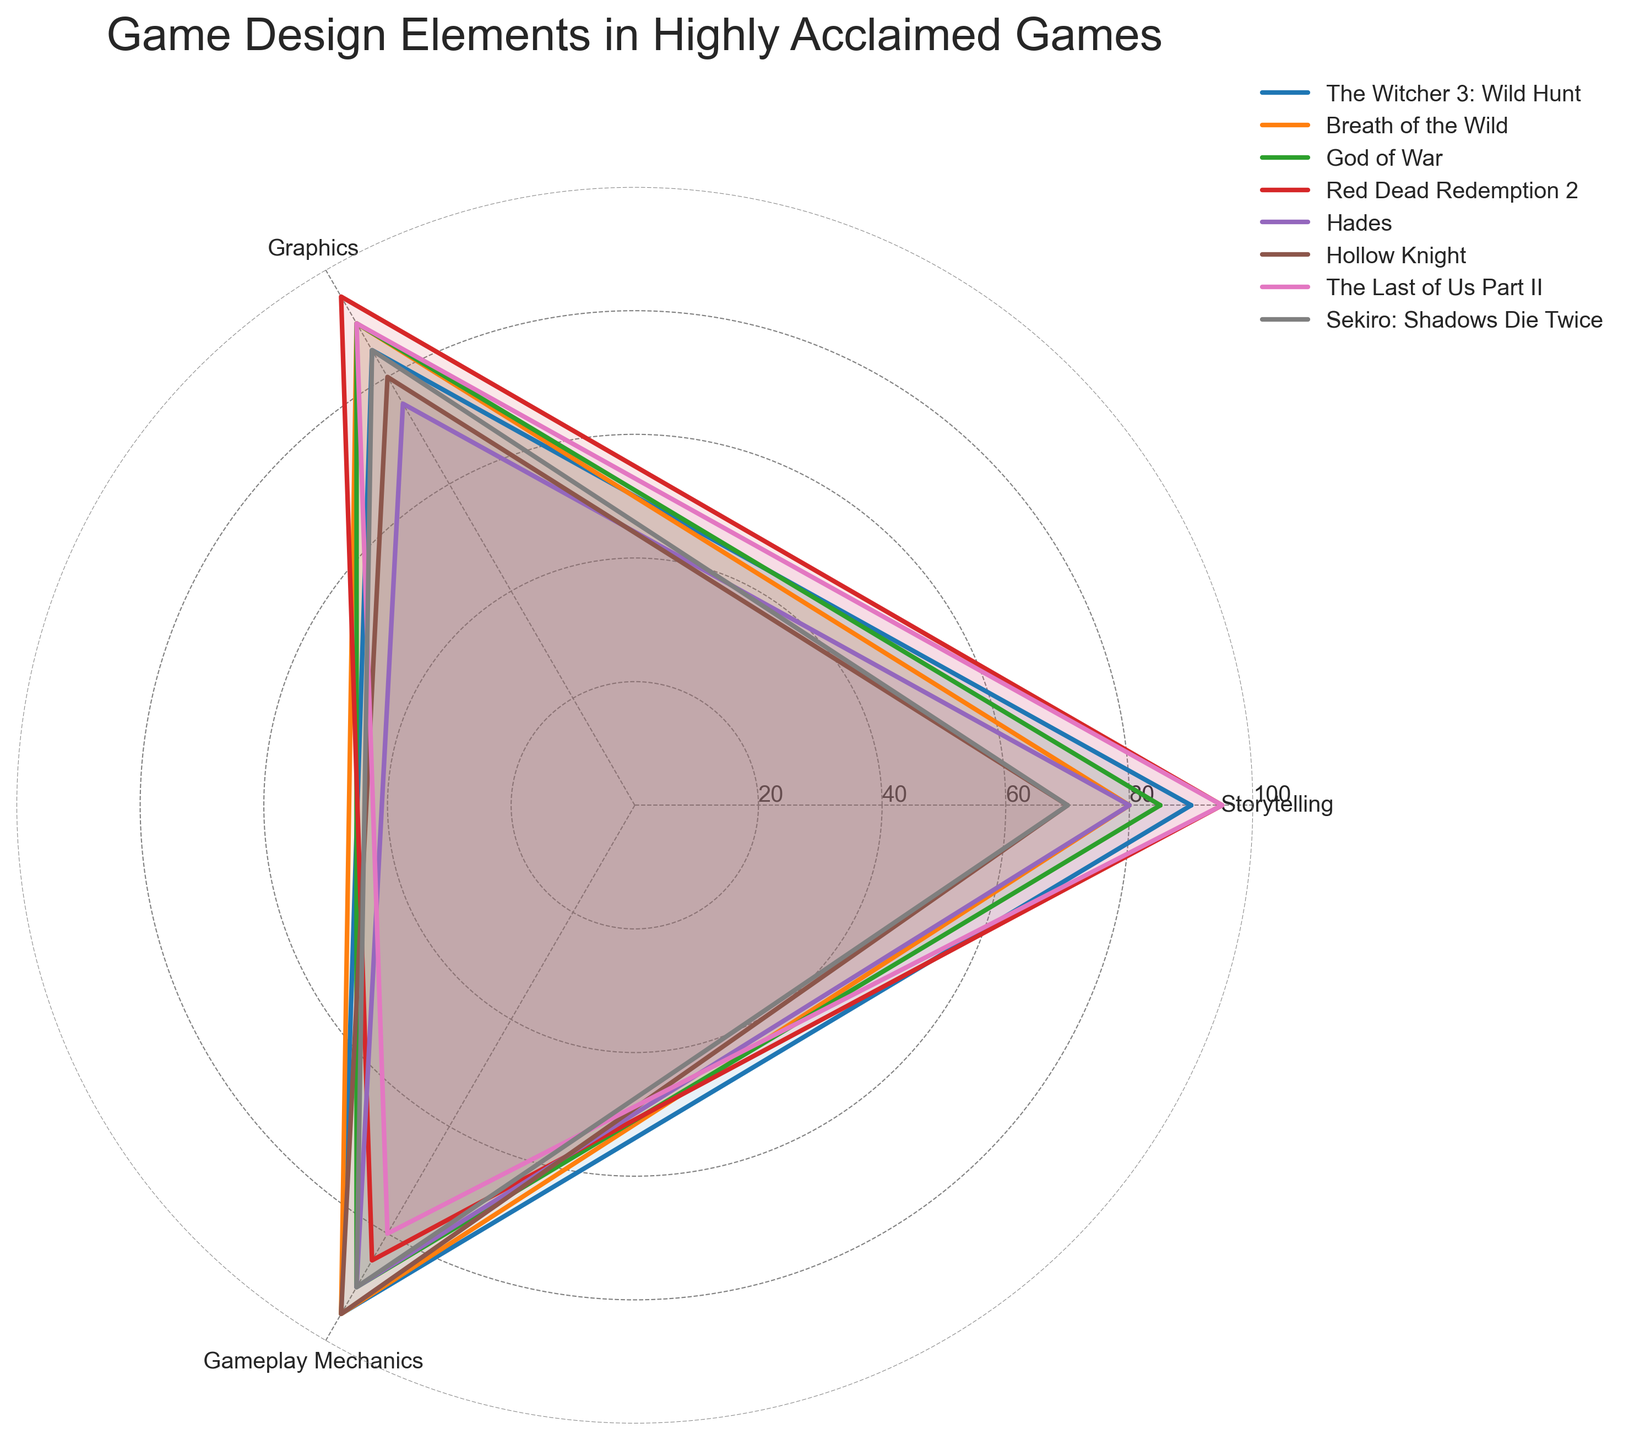what is the title of the plot? The title of the plot can be seen at the top of the figure. It usually describes what the plot is about.
Answer: "Game Design Elements in Highly Acclaimed Games" How many categories are compared in the radar chart? The categories are the labels around the edges of the radar chart. By counting these labels we can determine how many categories are compared.
Answer: 3 Which game has the highest value for Storytelling? Look for the segment labeled "Storytelling" and find the game that has the data point farthest from the center.
Answer: "Red Dead Redemption 2" and "The Last of Us Part II" Which game has the lowest average value across all categories? First, for each game, sum up their values for Storytelling, Graphics, and Gameplay Mechanics, then divide by 3. Compare these average values to find the lowest.
Answer: "Hollow Knight" Is the Gameplay Mechanics rating higher for God of War or The Witcher 3: Wild Hunt? Compare the data points in the segment labeled "Gameplay Mechanics" for both games.
Answer: "Tied" Which game has more emphasis on Storytelling compared to Graphics and Gameplay Mechanics? Find the game with a higher storytelling score relative to its scores in Graphics and Gameplay Mechanics. Visual inspection of the angles will help determine this.
Answer: "The Last of Us Part II" What is the range of Storytelling scores? Identify the highest and lowest values in the Storytelling segment and calculate the difference between these two values.
Answer: 25 Which games have equal scores in any category? Look for games that have the same score in any of the segments.
Answer: "God of War" and "The Last of Us Part II" (Graphics) How does Sekiro: Shadows Die Twice's Graphics score compare to Breath of the Wild's Graphics score? Identify the data points in the "Graphics" segment for both games and compare their distances from the center.
Answer: Lower 